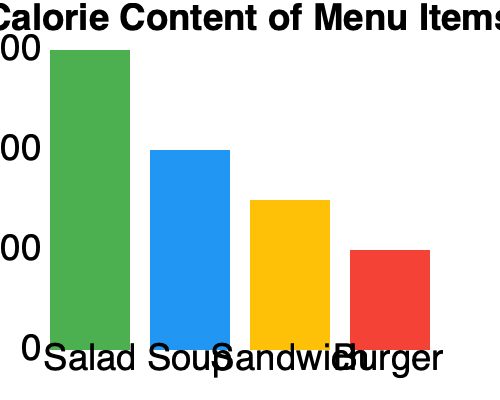As a professor who frequently dines at the restaurant, you're interested in recommending healthier options to your colleagues. Based on the bar chart showing the calorie content of different menu items, which two items would you suggest for a lighter meal, and what is their combined calorie count? To answer this question, we need to analyze the calorie content of each menu item shown in the bar chart:

1. Salad: The green bar reaches the 300 calorie mark.
2. Soup: The blue bar reaches the 200 calorie mark.
3. Sandwich: The yellow bar reaches the 150 calorie mark.
4. Burger: The red bar reaches the 100 calorie mark.

To recommend healthier options, we should choose the items with the lowest calorie content. In this case, the two items with the lowest calorie counts are:

1. Sandwich (150 calories)
2. Burger (100 calories)

To calculate the combined calorie count, we add these two values:

$150 + 100 = 250$ calories

Therefore, the sandwich and burger combination would provide the lightest meal option with a total of 250 calories.
Answer: Sandwich and Burger; 250 calories 